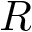Convert formula to latex. <formula><loc_0><loc_0><loc_500><loc_500>R</formula> 